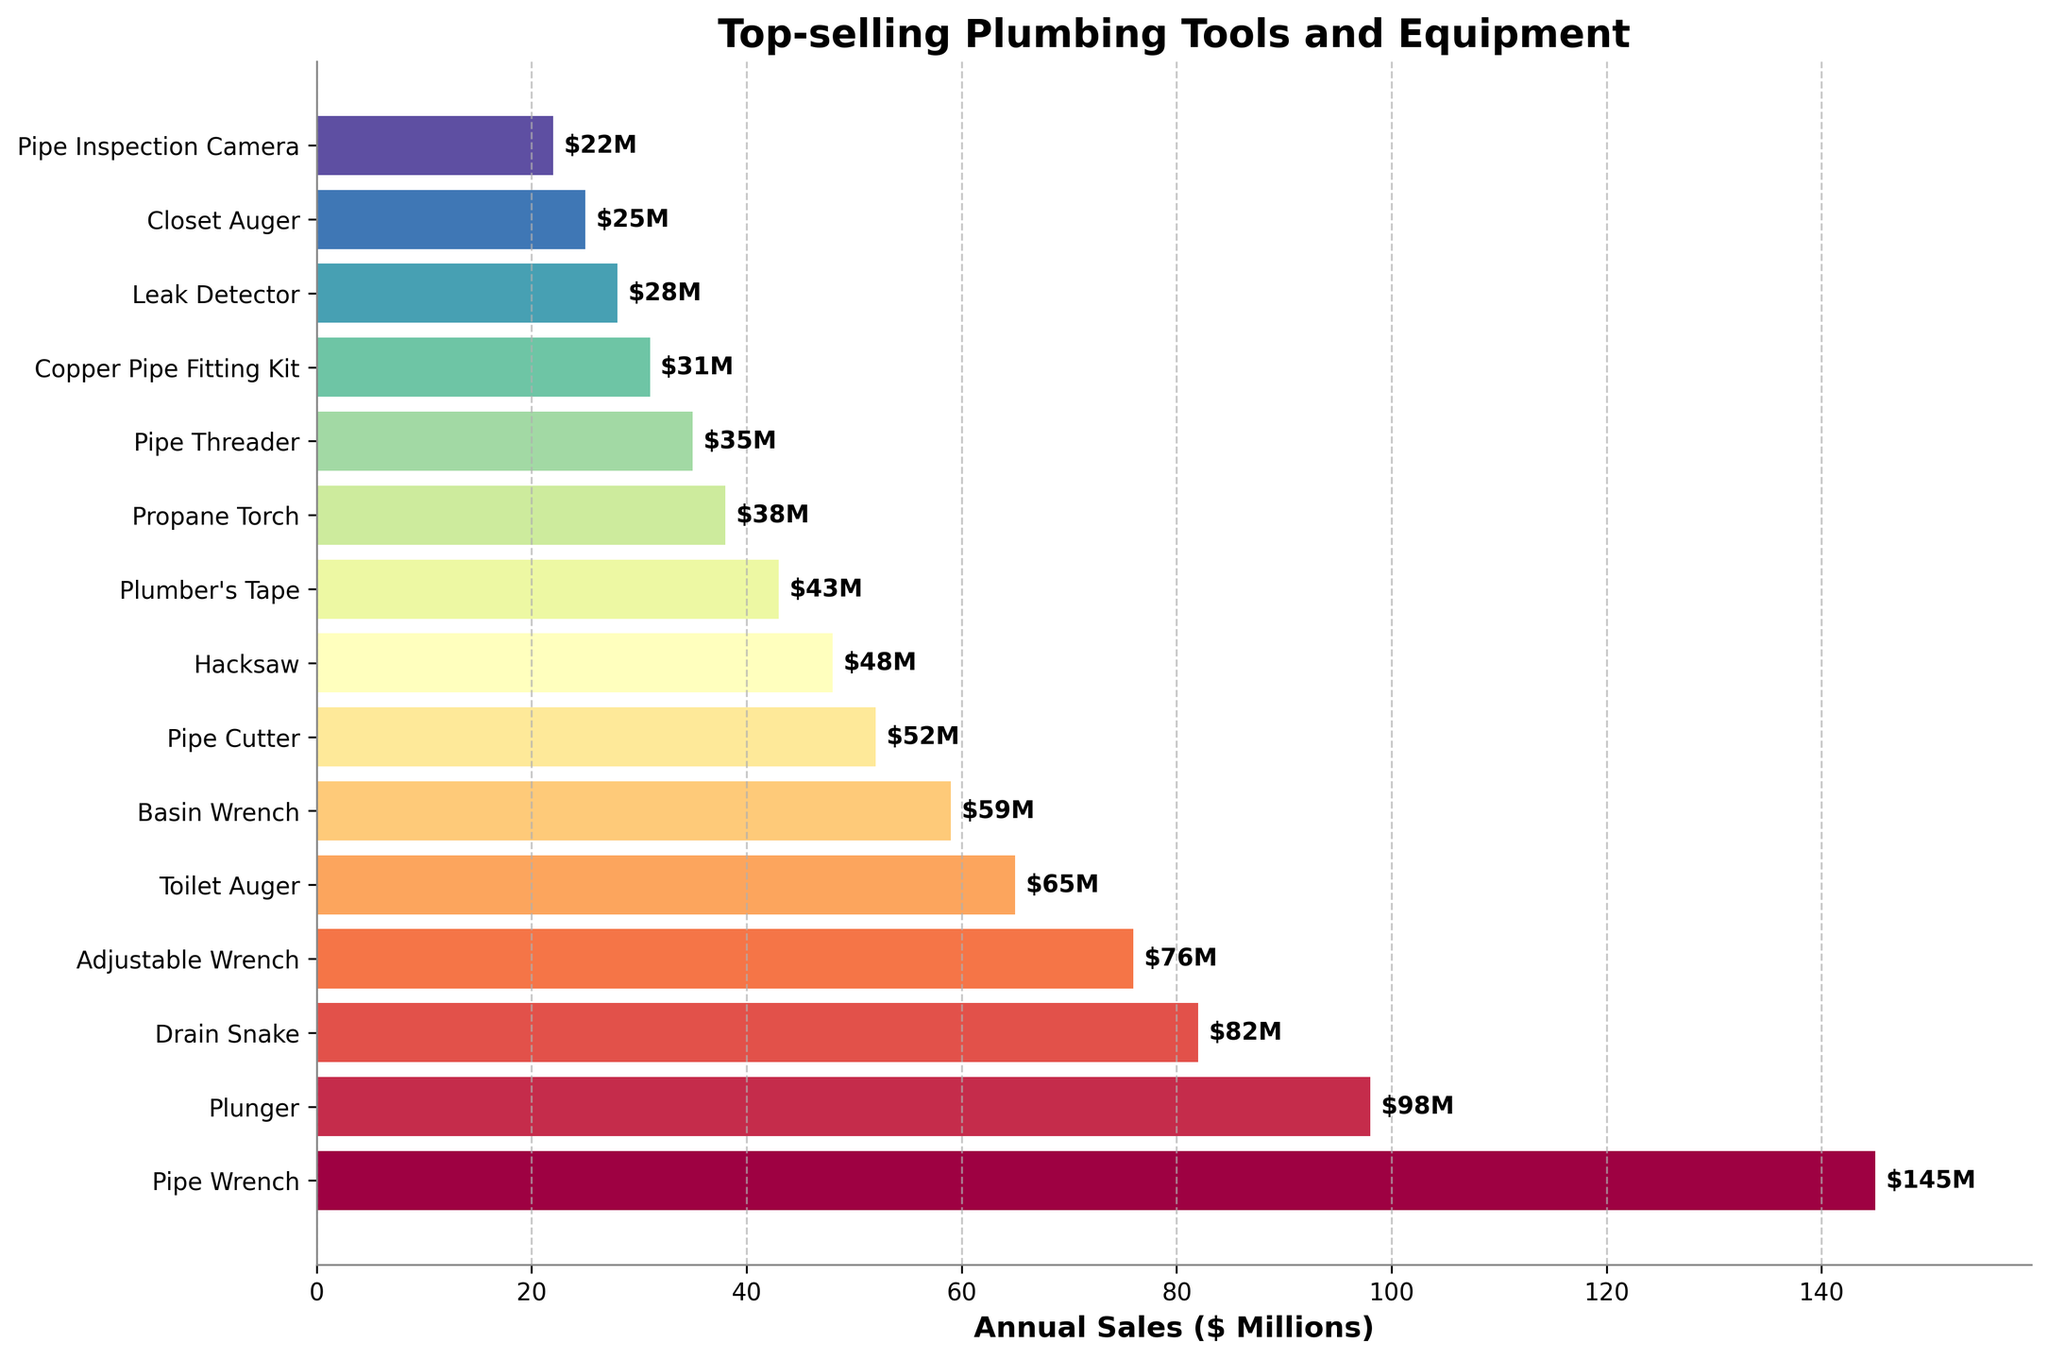Which tool has the highest annual sales? The tool with the highest annual sales is represented by the longest bar in the bar chart. The 'Pipe Wrench' has the highest sales figure of $145 million.
Answer: Pipe Wrench What is the total annual sales for the top three best-selling tools? To find the total, sum the annual sales of the top three tools: Pipe Wrench ($145M), Plunger ($98M), and Drain Snake ($82M). The total sum is $145M + $98M + $82M = $325M.
Answer: $325M Which tool has lower annual sales, the Basin Wrench or the Propane Torch? Compare the lengths of the bars representing Basin Wrench ($59M) and Propane Torch ($38M). The Propane Torch has lower annual sales ($38M < $59M).
Answer: Propane Torch How much more in annual sales does the Adjustable Wrench have compared to the Closet Auger? Subtract the annual sales of Closet Auger ($25M) from Adjustable Wrench ($76M). The difference is $76M - $25M = $51M.
Answer: $51M What is the average annual sales of the tools that have more than $50 million in sales? The tools with more than $50 million in sales are: Pipe Wrench ($145M), Plunger ($98M), Drain Snake ($82M), Adjustable Wrench ($76M), Toilet Auger ($65M), Basin Wrench ($59M), and Pipe Cutter ($52M). Sum these values ($577M) and divide by the number of tools (7). The average is $577M / 7 ≈ $82.43M.
Answer: $82.43M What is the color of the bar representing the Copper Pipe Fitting Kit? From the color gradient used, observe the Copper Pipe Fitting Kit’s bar and note its color. It is near the end of the list and has a particular shade based on the color scale used in the chart.
Answer: Purple (or specific color based on the gradient used) Which tool has the closest annual sales figure to $50 million? Identify the tools around $50 million in sales. Pipe Cutter has the closest figure to $50 million with $52 million.
Answer: Pipe Cutter Are there more tools with annual sales above or below $50 million? Count the number of tools with sales above $50M (Pipe Wrench, Plunger, Drain Snake, Adjustable Wrench, Toilet Auger, Basin Wrench, Pipe Cutter) which total 7 tools. For below $50M (Hacksaw, Plumber's Tape, Propane Torch, Pipe Threader, Copper Pipe Fitting Kit, Leak Detector, Closet Auger, Pipe Inspection Camera) there are 8 tools. More tools have sales below $50M.
Answer: Below Which tool has the median annual sales in the list? To determine the median, order the sales values and find the middle one: $145M, $98M, $82M, $76M, $65M, $59M, $52M, $48M, $43M, $38M, $35M, $31M, $28M, $25M, $22M. The middle value (8th in the ordered list) is $48M, represented by the Hacksaw.
Answer: Hacksaw What is the combined annual sales of all tools listed? Sum all the annual sales values: $145M + $98M + $82M + $76M + $65M + $59M + $52M + $48M + $43M + $38M + $35M + $31M + $28M + $25M + $22M. The total is $847M.
Answer: $847M 